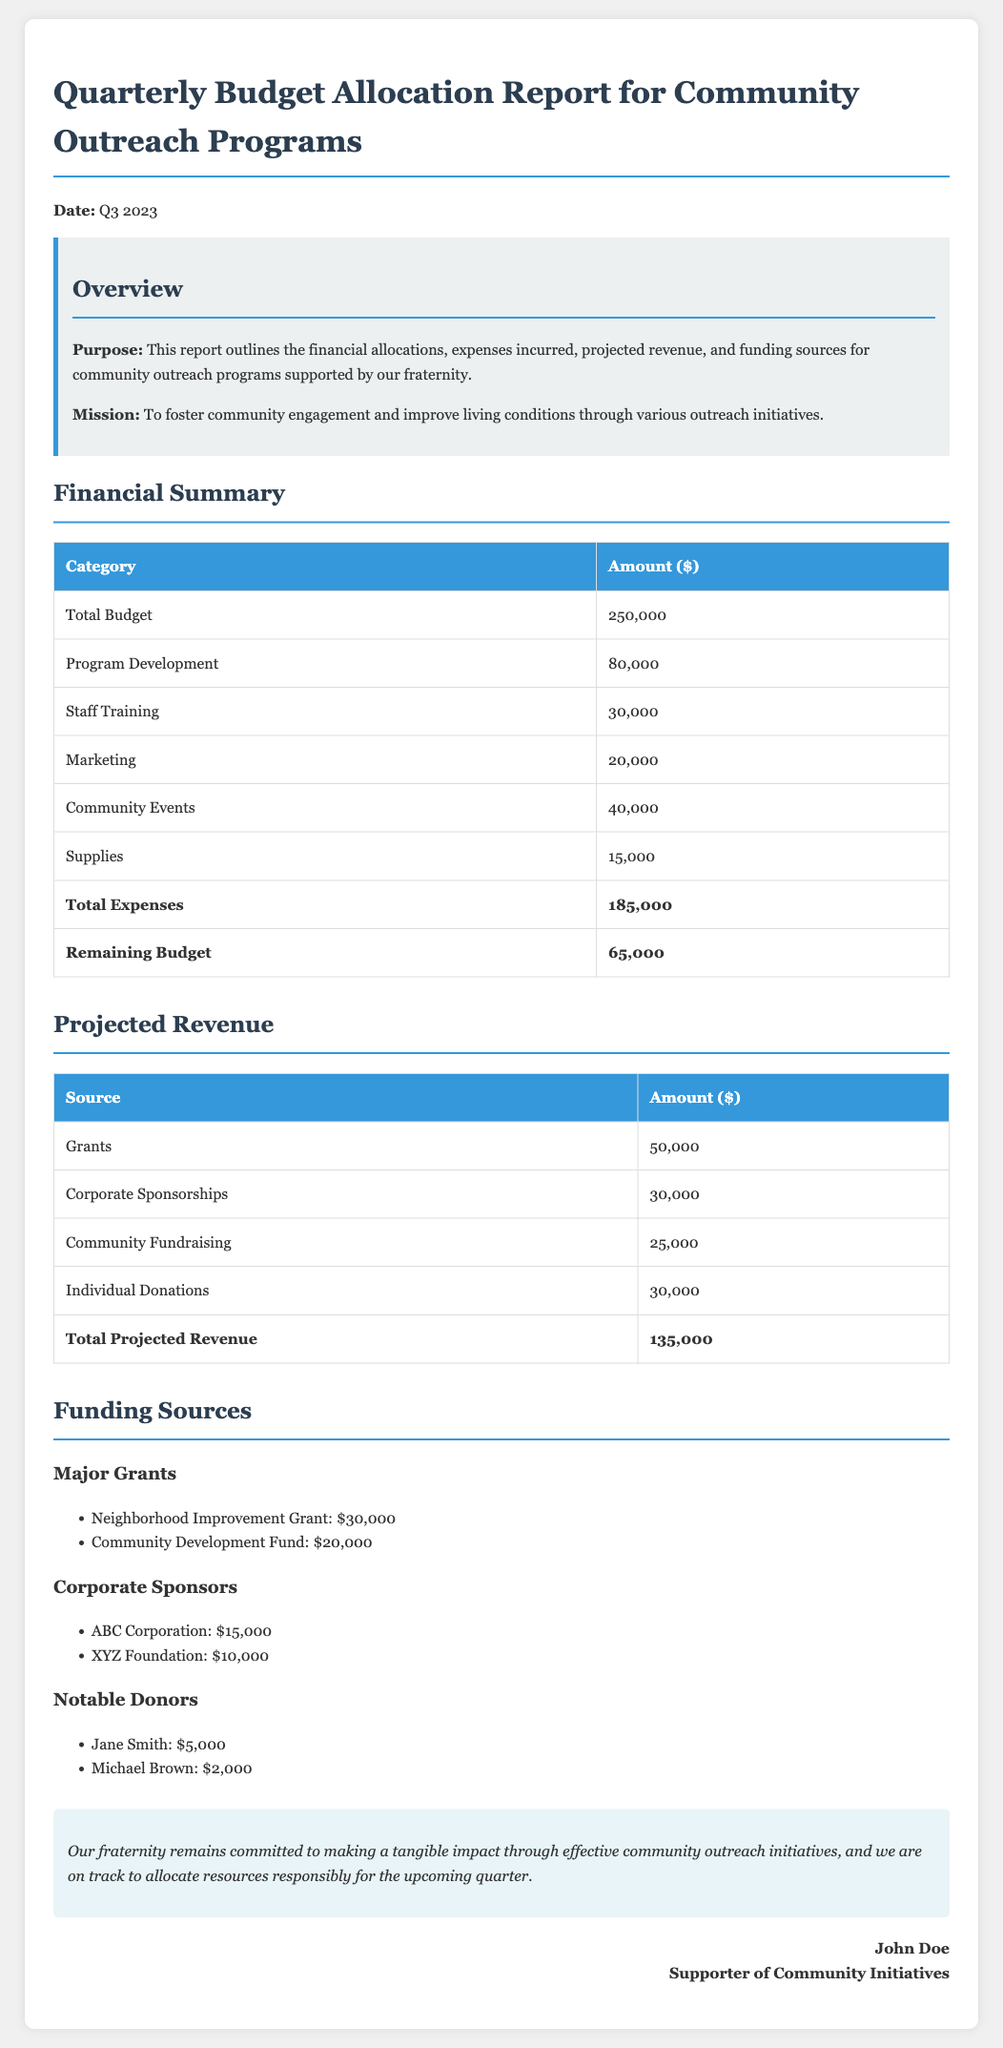What is the total budget? The total budget for community outreach programs as stated in the document is $250,000.
Answer: $250,000 What is the amount allocated for program development? The document specifies that the amount allocated for program development is $80,000.
Answer: $80,000 What is the total projected revenue? The total projected revenue is the sum of all revenue sources mentioned in the document, which equals $135,000.
Answer: $135,000 What are the major grants listed? The document lists the Neighborhood Improvement Grant and the Community Development Fund as major grants, totaling $50,000.
Answer: Neighborhood Improvement Grant, Community Development Fund How much is allocated for community events? According to the financial summary, the amount allocated for community events is $40,000.
Answer: $40,000 What is the remaining budget after expenses? The document indicates that the remaining budget after expenses is $65,000.
Answer: $65,000 What is the amount expected from corporate sponsorships? The expected amount from corporate sponsorships is $30,000 as mentioned in the projected revenue section.
Answer: $30,000 Which notable donor contributed $5,000? The document identifies Jane Smith as the notable donor who contributed $5,000.
Answer: Jane Smith What is the total expense amount? The total expenses listed in the financial summary amount to $185,000.
Answer: $185,000 